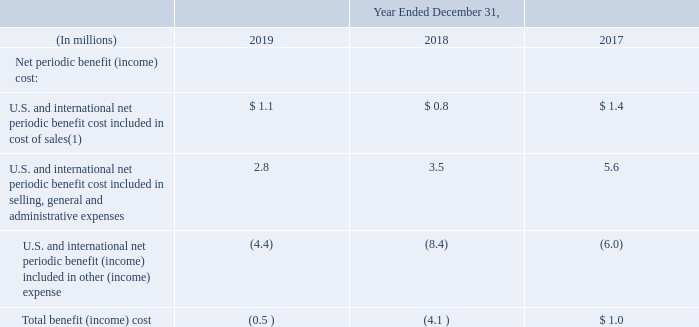Defined Benefit Pension Plans
We recognize the funded status of each defined pension benefit plan as the difference between the fair value of plan assets and the projected benefit obligation of the employee benefit plans in the Consolidated Balance Sheets, with a corresponding adjustment to accumulated other comprehensive loss, net of taxes. Each overfunded plan is recognized as an asset and each underfunded plan is recognized as a liability on our Consolidated Balance Sheets. Subsequent changes in the funded status are reflected on the Consolidated Balance Sheets in unrecognized pension items, a component of AOCL, which are included in total stockholders’ deficit. The amount of unamortized pension items is recorded net of tax.
We have amortized actuarial gains or losses over the average future working lifetime (or remaining lifetime of inactive participants if there are no active participants). We have used the corridor method, where the corridor is the greater of ten percent of the projected benefit obligation or fair value of assets at year end. If actuarial gains or losses do not exceed the corridor, then there is no amortization of gain or loss.
During the year ended December 31, 2017, several of our pension plans transferred in the sale of Diversey. Two international plans were split between Diversey and Sealed Air at the close of the sale. Unless noted, the tables in this disclosure show only activity related to plans retained by Sealed Air.
The following table shows the components of our net periodic benefit cost for the three years ended December 31, for our pension plans charged to operations:
(1) The amount recorded in inventory for the years ended December 31, 2019, 2018 and 2017 was not material.
How was amortization of actuarial gains or losses over the average future working lifetime (or remaining lifetime of inactive participants if there are no active participants)? The corridor method, where the corridor is the greater of ten percent of the projected benefit obligation or fair value of assets at year end. if actuarial gains or losses do not exceed the corridor, then there is no amortization of gain or loss. What does the table show? Shows the components of our net periodic benefit cost for the three years ended december 31, for our pension plans charged to operations. What occured during the year ended December 31, 2017? Several of our pension plans transferred in the sale of diversey. two international plans were split between diversey and sealed air at the close of the sale. What is the average annual Total benefit (income) cost?
Answer scale should be: million. (-0.5+-4.1+1)/3
Answer: -1.2. What is the percentage difference of the U.S. and international net periodic benefit cost included in cost of sales for year 2017 to year 2019?
Answer scale should be: percent. (1.1-1.4)/1.4
Answer: -21.43. What is the U.S. and international net periodic benefit cost included in cost of sales expressed as a percentage of U.S. and international net periodic benefit cost included in selling, general and administrative expenses of 2019?
Answer scale should be: percent. 1.1/2.8
Answer: 39.29. 